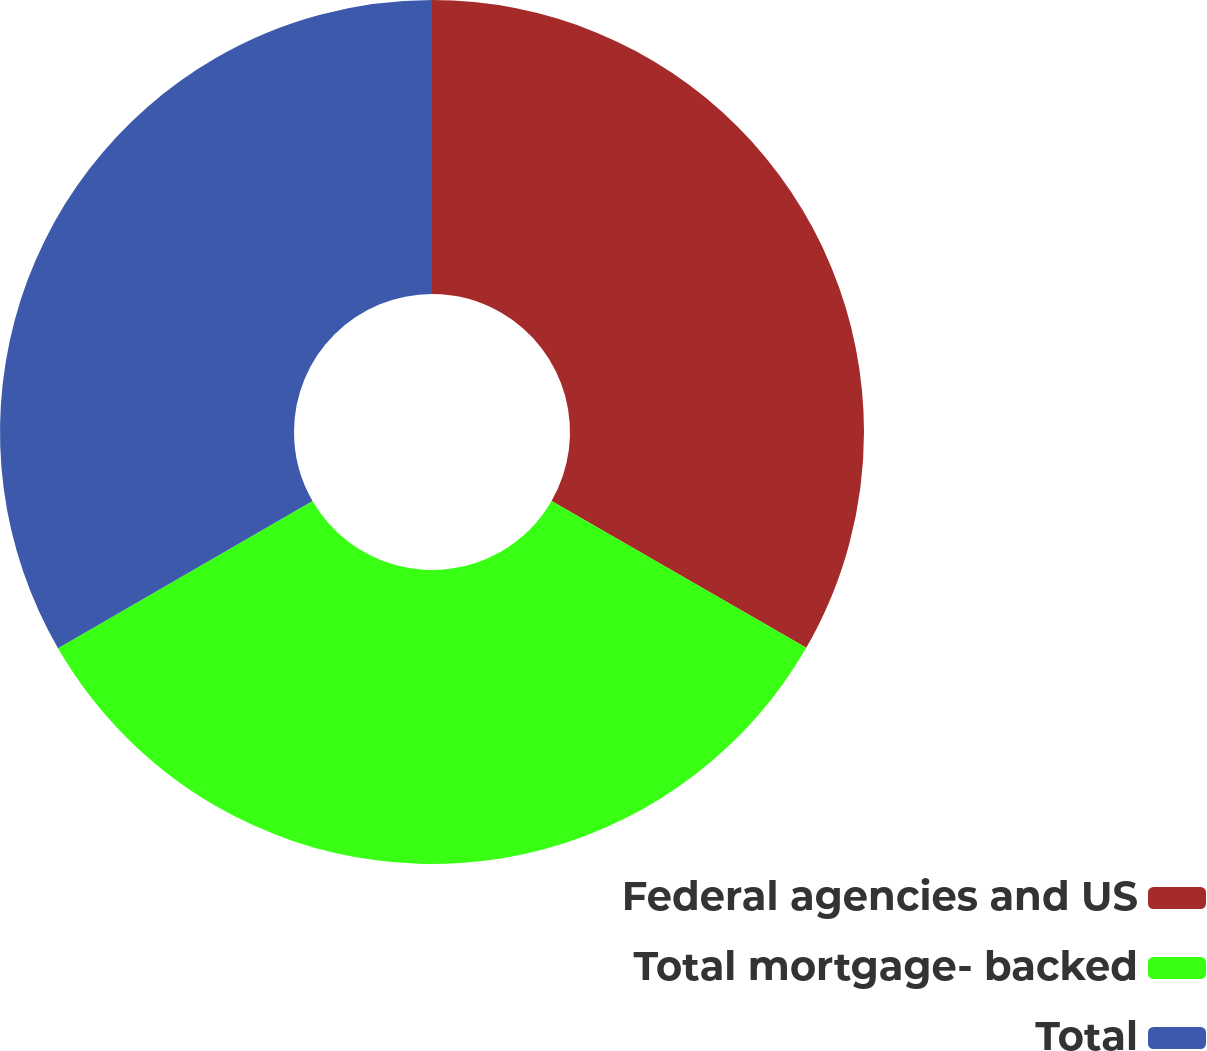Convert chart to OTSL. <chart><loc_0><loc_0><loc_500><loc_500><pie_chart><fcel>Federal agencies and US<fcel>Total mortgage- backed<fcel>Total<nl><fcel>33.32%<fcel>33.33%<fcel>33.34%<nl></chart> 